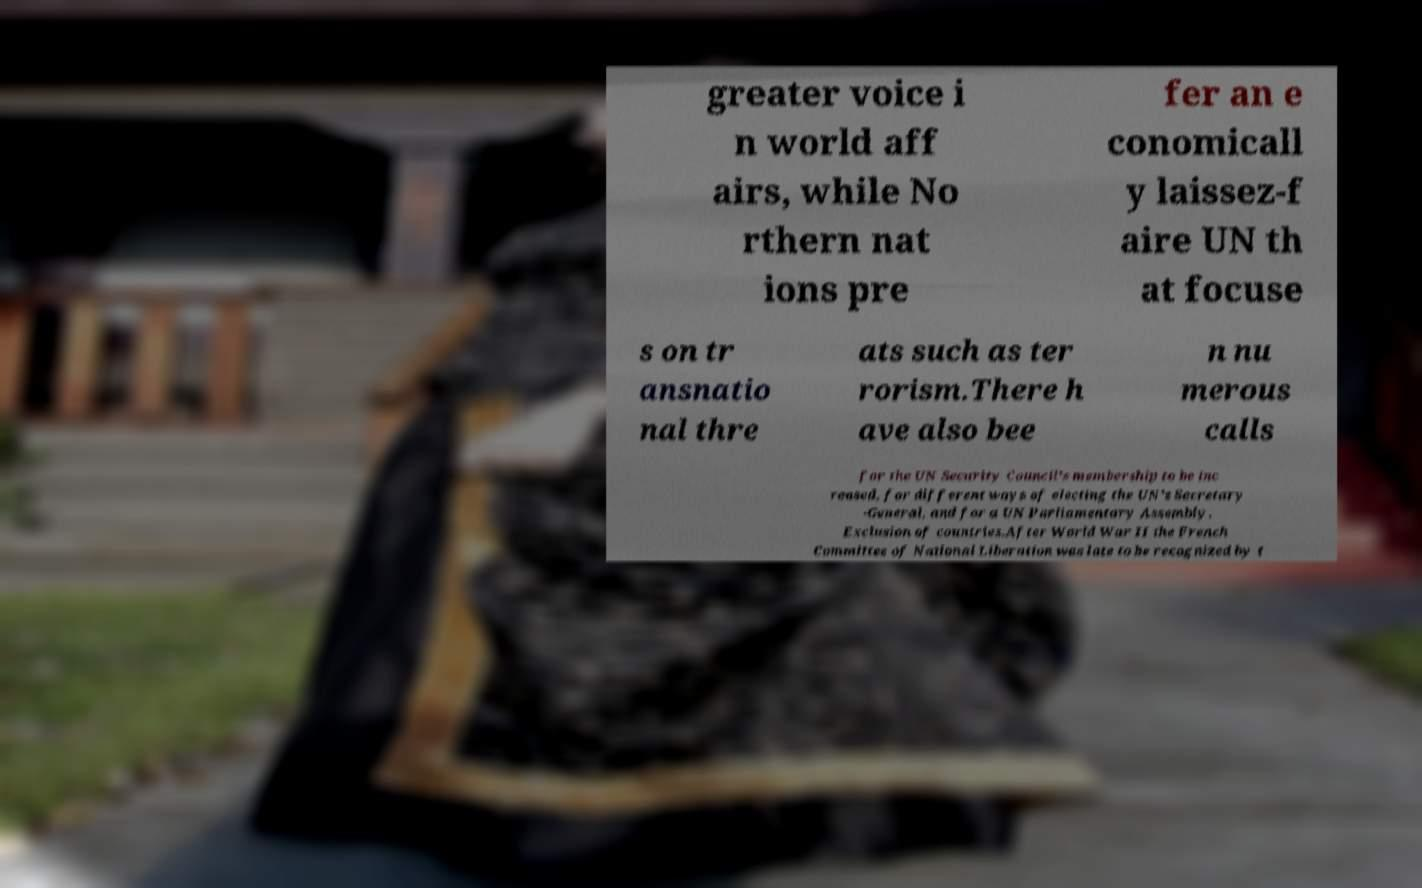Could you assist in decoding the text presented in this image and type it out clearly? greater voice i n world aff airs, while No rthern nat ions pre fer an e conomicall y laissez-f aire UN th at focuse s on tr ansnatio nal thre ats such as ter rorism.There h ave also bee n nu merous calls for the UN Security Council's membership to be inc reased, for different ways of electing the UN's Secretary -General, and for a UN Parliamentary Assembly. Exclusion of countries.After World War II the French Committee of National Liberation was late to be recognized by t 